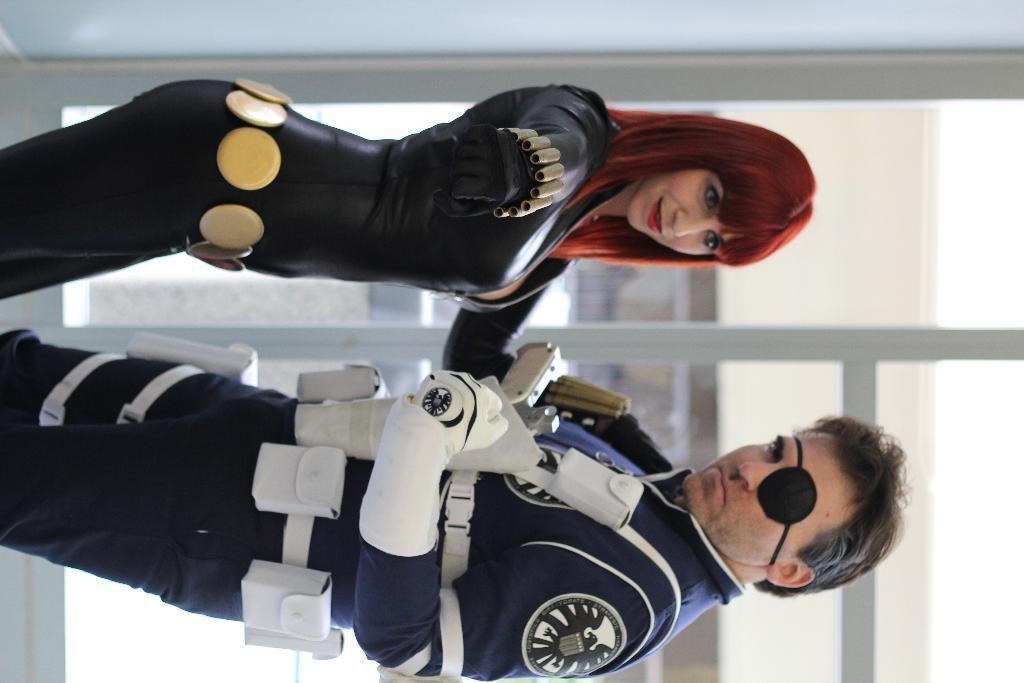What are the two people in the image doing? The lady and the man are standing in the image. Can you describe the two people in the image? There is a lady and a man in the image. What is visible in the background of the image? There is a door in the background of the image. What type of gun can be seen in the hands of the lady in the image? There is no gun present in the image; the lady and the man are simply standing. How many cups are visible on the table in the image? There is no table or cup present in the image. 